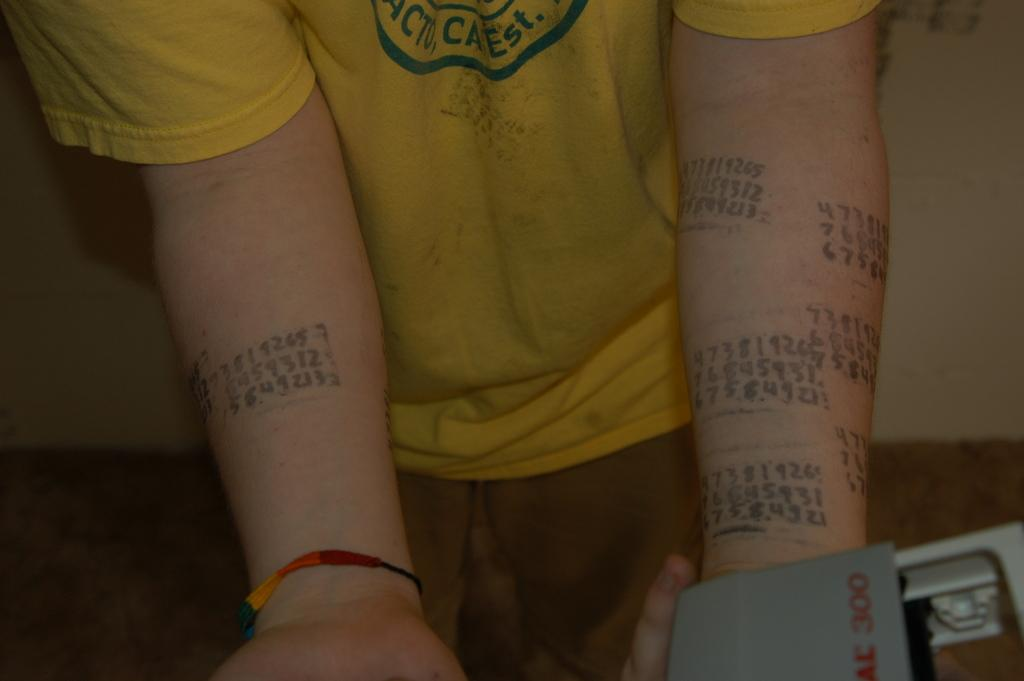What is the main subject of the image? There is a person standing in the image. What is the person doing with their hands? The person is showing their hands in the image. Are there any distinguishing features on the person's hands? Yes, there are tattoos visible on the person's hands. What is the person holding in one hand? The person is holding something in one hand, but we cannot determine what it is from the image. What can be seen in the background of the image? There is a wall in the background of the image. How many cattle are grazing on the edge of the town in the image? There are no cattle or town present in the image; it features a person standing with their hands showing. 